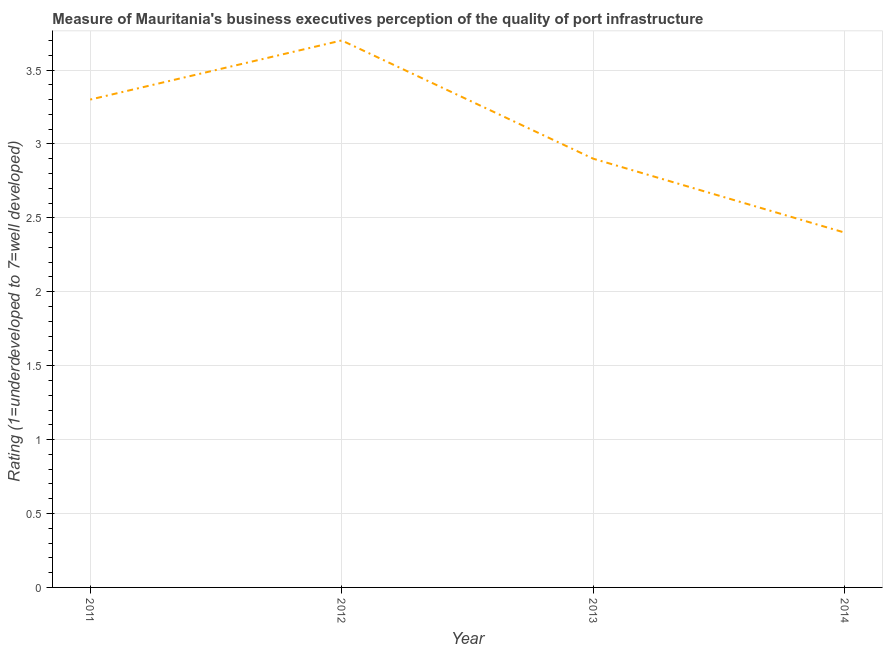What is the rating measuring quality of port infrastructure in 2012?
Provide a succinct answer. 3.7. Across all years, what is the minimum rating measuring quality of port infrastructure?
Provide a short and direct response. 2.4. In which year was the rating measuring quality of port infrastructure minimum?
Provide a short and direct response. 2014. What is the sum of the rating measuring quality of port infrastructure?
Your answer should be compact. 12.3. What is the difference between the rating measuring quality of port infrastructure in 2011 and 2014?
Give a very brief answer. 0.9. What is the average rating measuring quality of port infrastructure per year?
Your answer should be very brief. 3.08. What is the median rating measuring quality of port infrastructure?
Offer a very short reply. 3.1. Do a majority of the years between 2013 and 2014 (inclusive) have rating measuring quality of port infrastructure greater than 2.7 ?
Your answer should be very brief. No. What is the ratio of the rating measuring quality of port infrastructure in 2011 to that in 2012?
Give a very brief answer. 0.89. Is the rating measuring quality of port infrastructure in 2011 less than that in 2012?
Your answer should be compact. Yes. What is the difference between the highest and the second highest rating measuring quality of port infrastructure?
Give a very brief answer. 0.4. Is the sum of the rating measuring quality of port infrastructure in 2011 and 2014 greater than the maximum rating measuring quality of port infrastructure across all years?
Provide a succinct answer. Yes. What is the difference between the highest and the lowest rating measuring quality of port infrastructure?
Make the answer very short. 1.3. Does the rating measuring quality of port infrastructure monotonically increase over the years?
Make the answer very short. No. How many lines are there?
Your answer should be very brief. 1. What is the difference between two consecutive major ticks on the Y-axis?
Your answer should be compact. 0.5. Does the graph contain any zero values?
Your answer should be compact. No. Does the graph contain grids?
Your answer should be very brief. Yes. What is the title of the graph?
Your response must be concise. Measure of Mauritania's business executives perception of the quality of port infrastructure. What is the label or title of the Y-axis?
Your response must be concise. Rating (1=underdeveloped to 7=well developed) . What is the difference between the Rating (1=underdeveloped to 7=well developed)  in 2011 and 2013?
Keep it short and to the point. 0.4. What is the difference between the Rating (1=underdeveloped to 7=well developed)  in 2012 and 2014?
Your answer should be compact. 1.3. What is the ratio of the Rating (1=underdeveloped to 7=well developed)  in 2011 to that in 2012?
Provide a succinct answer. 0.89. What is the ratio of the Rating (1=underdeveloped to 7=well developed)  in 2011 to that in 2013?
Your answer should be compact. 1.14. What is the ratio of the Rating (1=underdeveloped to 7=well developed)  in 2011 to that in 2014?
Keep it short and to the point. 1.38. What is the ratio of the Rating (1=underdeveloped to 7=well developed)  in 2012 to that in 2013?
Your answer should be compact. 1.28. What is the ratio of the Rating (1=underdeveloped to 7=well developed)  in 2012 to that in 2014?
Your response must be concise. 1.54. What is the ratio of the Rating (1=underdeveloped to 7=well developed)  in 2013 to that in 2014?
Ensure brevity in your answer.  1.21. 